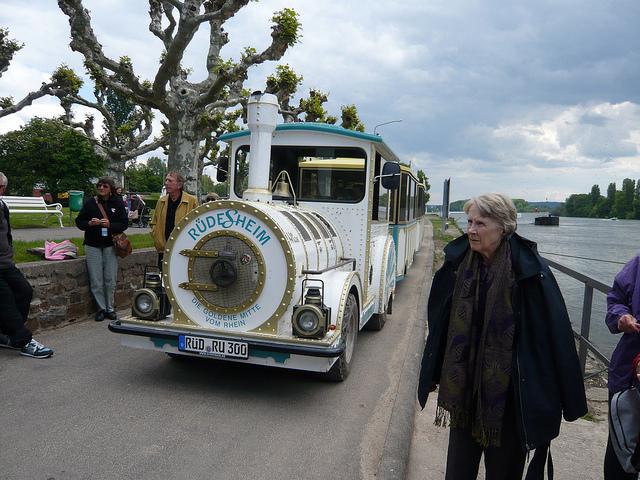Does this road run parallel to a river?
Concise answer only. Yes. What type of trees are on the raised area?
Give a very brief answer. Oak. What are the last three digits of plate number?
Answer briefly. 300. 